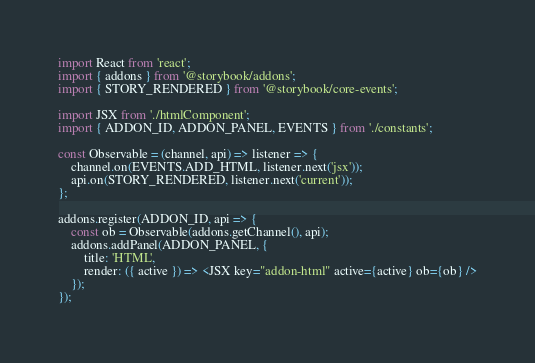<code> <loc_0><loc_0><loc_500><loc_500><_JavaScript_>import React from 'react';
import { addons } from '@storybook/addons';
import { STORY_RENDERED } from '@storybook/core-events';

import JSX from './htmlComponent';
import { ADDON_ID, ADDON_PANEL, EVENTS } from './constants';

const Observable = (channel, api) => listener => {
	channel.on(EVENTS.ADD_HTML, listener.next('jsx'));
	api.on(STORY_RENDERED, listener.next('current'));
};

addons.register(ADDON_ID, api => {
	const ob = Observable(addons.getChannel(), api);
	addons.addPanel(ADDON_PANEL, {
		title: 'HTML',
		render: ({ active }) => <JSX key="addon-html" active={active} ob={ob} />
	});
});
</code> 